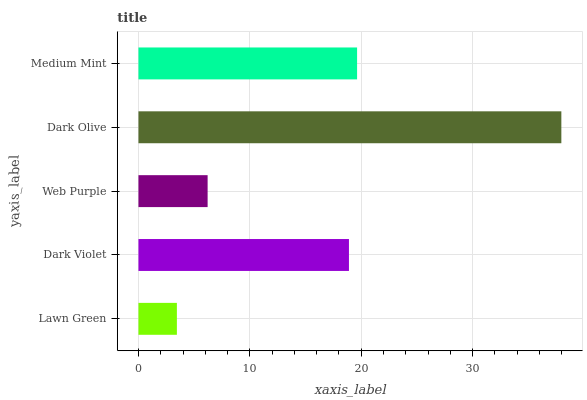Is Lawn Green the minimum?
Answer yes or no. Yes. Is Dark Olive the maximum?
Answer yes or no. Yes. Is Dark Violet the minimum?
Answer yes or no. No. Is Dark Violet the maximum?
Answer yes or no. No. Is Dark Violet greater than Lawn Green?
Answer yes or no. Yes. Is Lawn Green less than Dark Violet?
Answer yes or no. Yes. Is Lawn Green greater than Dark Violet?
Answer yes or no. No. Is Dark Violet less than Lawn Green?
Answer yes or no. No. Is Dark Violet the high median?
Answer yes or no. Yes. Is Dark Violet the low median?
Answer yes or no. Yes. Is Dark Olive the high median?
Answer yes or no. No. Is Web Purple the low median?
Answer yes or no. No. 